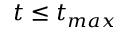<formula> <loc_0><loc_0><loc_500><loc_500>t \leq t _ { \max }</formula> 